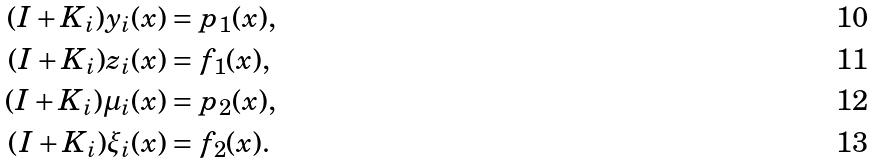Convert formula to latex. <formula><loc_0><loc_0><loc_500><loc_500>( I + K _ { i } ) y _ { i } ( x ) & = p _ { 1 } ( x ) , \\ ( I + K _ { i } ) z _ { i } ( x ) & = f _ { 1 } ( x ) , \\ ( I + K _ { i } ) { \mu } _ { i } ( x ) & = p _ { 2 } ( x ) , \\ ( I + K _ { i } ) { \xi } _ { i } ( x ) & = f _ { 2 } ( x ) .</formula> 